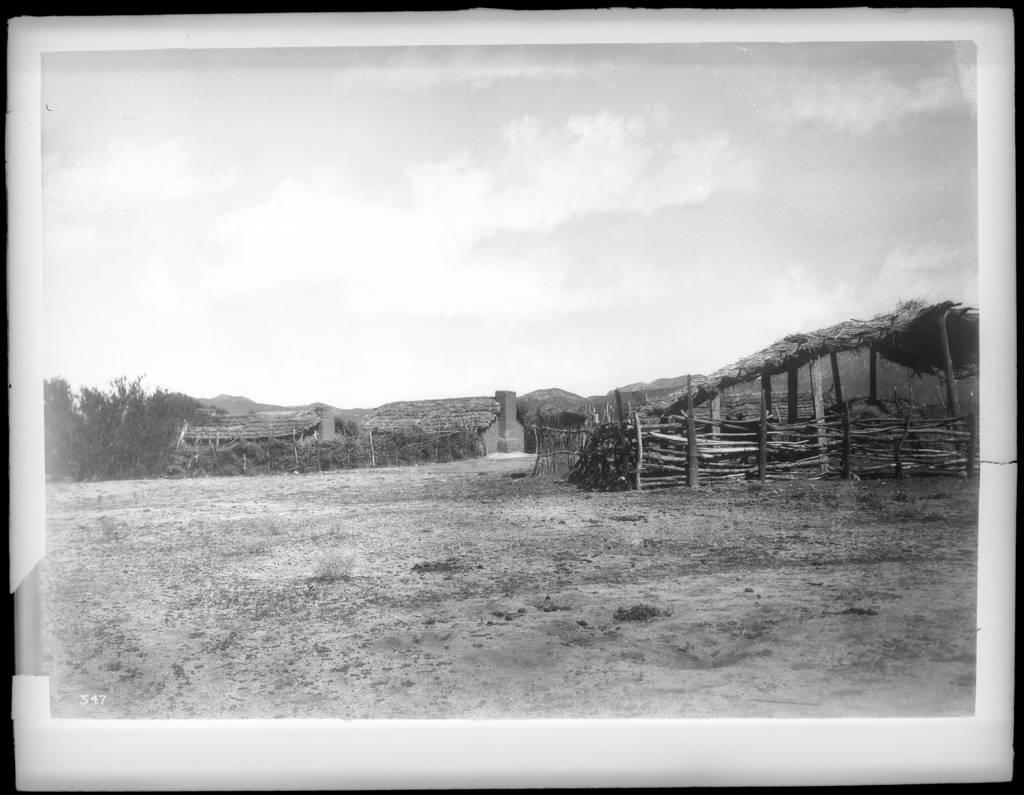What type of structure can be seen in the image? There is a fence in the image. What type of dwelling is present in the image? There are huts in the image. What type of vegetation is visible in the image? There are trees in the image. What is visible in the background of the image? The sky is visible in the image. Can you see any ants crawling on the fence in the image? There are no ants visible in the image. Is there a flame visible in the image? There is no flame present in the image. 